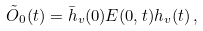Convert formula to latex. <formula><loc_0><loc_0><loc_500><loc_500>\tilde { O } _ { 0 } ( t ) = \bar { h } _ { v } ( 0 ) E ( 0 , t ) h _ { v } ( t ) \, ,</formula> 